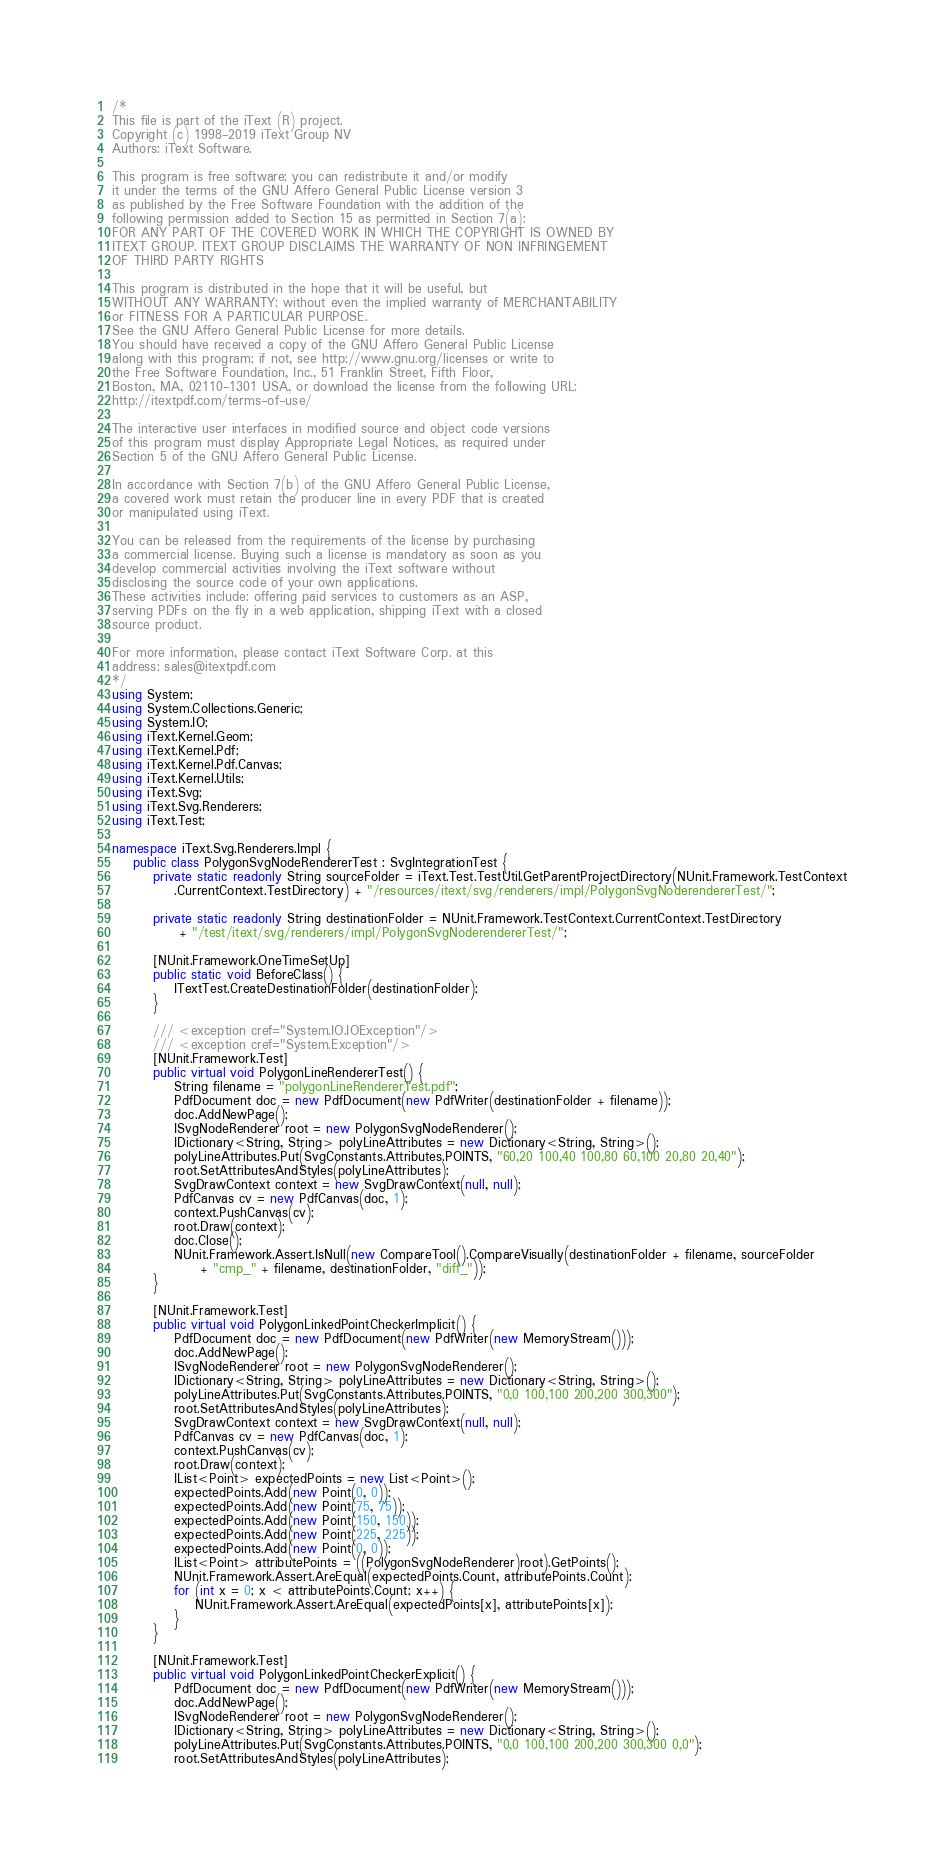<code> <loc_0><loc_0><loc_500><loc_500><_C#_>/*
This file is part of the iText (R) project.
Copyright (c) 1998-2019 iText Group NV
Authors: iText Software.

This program is free software; you can redistribute it and/or modify
it under the terms of the GNU Affero General Public License version 3
as published by the Free Software Foundation with the addition of the
following permission added to Section 15 as permitted in Section 7(a):
FOR ANY PART OF THE COVERED WORK IN WHICH THE COPYRIGHT IS OWNED BY
ITEXT GROUP. ITEXT GROUP DISCLAIMS THE WARRANTY OF NON INFRINGEMENT
OF THIRD PARTY RIGHTS

This program is distributed in the hope that it will be useful, but
WITHOUT ANY WARRANTY; without even the implied warranty of MERCHANTABILITY
or FITNESS FOR A PARTICULAR PURPOSE.
See the GNU Affero General Public License for more details.
You should have received a copy of the GNU Affero General Public License
along with this program; if not, see http://www.gnu.org/licenses or write to
the Free Software Foundation, Inc., 51 Franklin Street, Fifth Floor,
Boston, MA, 02110-1301 USA, or download the license from the following URL:
http://itextpdf.com/terms-of-use/

The interactive user interfaces in modified source and object code versions
of this program must display Appropriate Legal Notices, as required under
Section 5 of the GNU Affero General Public License.

In accordance with Section 7(b) of the GNU Affero General Public License,
a covered work must retain the producer line in every PDF that is created
or manipulated using iText.

You can be released from the requirements of the license by purchasing
a commercial license. Buying such a license is mandatory as soon as you
develop commercial activities involving the iText software without
disclosing the source code of your own applications.
These activities include: offering paid services to customers as an ASP,
serving PDFs on the fly in a web application, shipping iText with a closed
source product.

For more information, please contact iText Software Corp. at this
address: sales@itextpdf.com
*/
using System;
using System.Collections.Generic;
using System.IO;
using iText.Kernel.Geom;
using iText.Kernel.Pdf;
using iText.Kernel.Pdf.Canvas;
using iText.Kernel.Utils;
using iText.Svg;
using iText.Svg.Renderers;
using iText.Test;

namespace iText.Svg.Renderers.Impl {
    public class PolygonSvgNodeRendererTest : SvgIntegrationTest {
        private static readonly String sourceFolder = iText.Test.TestUtil.GetParentProjectDirectory(NUnit.Framework.TestContext
            .CurrentContext.TestDirectory) + "/resources/itext/svg/renderers/impl/PolygonSvgNoderendererTest/";

        private static readonly String destinationFolder = NUnit.Framework.TestContext.CurrentContext.TestDirectory
             + "/test/itext/svg/renderers/impl/PolygonSvgNoderendererTest/";

        [NUnit.Framework.OneTimeSetUp]
        public static void BeforeClass() {
            ITextTest.CreateDestinationFolder(destinationFolder);
        }

        /// <exception cref="System.IO.IOException"/>
        /// <exception cref="System.Exception"/>
        [NUnit.Framework.Test]
        public virtual void PolygonLineRendererTest() {
            String filename = "polygonLineRendererTest.pdf";
            PdfDocument doc = new PdfDocument(new PdfWriter(destinationFolder + filename));
            doc.AddNewPage();
            ISvgNodeRenderer root = new PolygonSvgNodeRenderer();
            IDictionary<String, String> polyLineAttributes = new Dictionary<String, String>();
            polyLineAttributes.Put(SvgConstants.Attributes.POINTS, "60,20 100,40 100,80 60,100 20,80 20,40");
            root.SetAttributesAndStyles(polyLineAttributes);
            SvgDrawContext context = new SvgDrawContext(null, null);
            PdfCanvas cv = new PdfCanvas(doc, 1);
            context.PushCanvas(cv);
            root.Draw(context);
            doc.Close();
            NUnit.Framework.Assert.IsNull(new CompareTool().CompareVisually(destinationFolder + filename, sourceFolder
                 + "cmp_" + filename, destinationFolder, "diff_"));
        }

        [NUnit.Framework.Test]
        public virtual void PolygonLinkedPointCheckerImplicit() {
            PdfDocument doc = new PdfDocument(new PdfWriter(new MemoryStream()));
            doc.AddNewPage();
            ISvgNodeRenderer root = new PolygonSvgNodeRenderer();
            IDictionary<String, String> polyLineAttributes = new Dictionary<String, String>();
            polyLineAttributes.Put(SvgConstants.Attributes.POINTS, "0,0 100,100 200,200 300,300");
            root.SetAttributesAndStyles(polyLineAttributes);
            SvgDrawContext context = new SvgDrawContext(null, null);
            PdfCanvas cv = new PdfCanvas(doc, 1);
            context.PushCanvas(cv);
            root.Draw(context);
            IList<Point> expectedPoints = new List<Point>();
            expectedPoints.Add(new Point(0, 0));
            expectedPoints.Add(new Point(75, 75));
            expectedPoints.Add(new Point(150, 150));
            expectedPoints.Add(new Point(225, 225));
            expectedPoints.Add(new Point(0, 0));
            IList<Point> attributePoints = ((PolygonSvgNodeRenderer)root).GetPoints();
            NUnit.Framework.Assert.AreEqual(expectedPoints.Count, attributePoints.Count);
            for (int x = 0; x < attributePoints.Count; x++) {
                NUnit.Framework.Assert.AreEqual(expectedPoints[x], attributePoints[x]);
            }
        }

        [NUnit.Framework.Test]
        public virtual void PolygonLinkedPointCheckerExplicit() {
            PdfDocument doc = new PdfDocument(new PdfWriter(new MemoryStream()));
            doc.AddNewPage();
            ISvgNodeRenderer root = new PolygonSvgNodeRenderer();
            IDictionary<String, String> polyLineAttributes = new Dictionary<String, String>();
            polyLineAttributes.Put(SvgConstants.Attributes.POINTS, "0,0 100,100 200,200 300,300 0,0");
            root.SetAttributesAndStyles(polyLineAttributes);</code> 